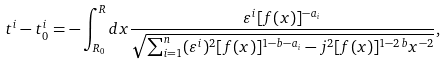<formula> <loc_0><loc_0><loc_500><loc_500>t ^ { i } - t _ { 0 } ^ { i } = - \int _ { R _ { 0 } } ^ { R } d x \frac { \varepsilon ^ { i } [ { f } ( x ) ] ^ { - a _ { i } } } { \sqrt { \sum _ { i = 1 } ^ { n } ( \varepsilon ^ { i } ) ^ { 2 } [ { f } ( x ) ] ^ { 1 - b - a _ { i } } - j ^ { 2 } [ { f } ( x ) ] ^ { 1 - 2 b } x ^ { - 2 } } } ,</formula> 